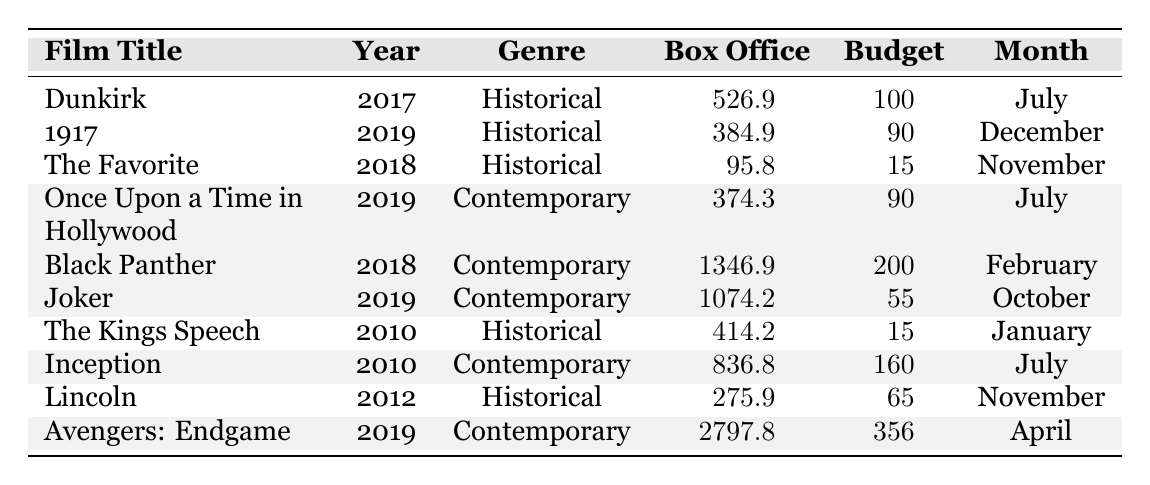What is the box office gross of "Dunkirk"? The table lists "Dunkirk" under the Historical Drama genre with a box office gross of 526.9 million.
Answer: 526.9 million How many historical drama films are in the table? The films categorized as Historical Drama are "Dunkirk," "1917," "The Favorite," "The Kings Speech," and "Lincoln," totaling five films.
Answer: 5 Which film had the highest box office gross, and what was its amount? The film with the highest box office gross is "Avengers: Endgame," at 2797.8 million, which is indicated in the table.
Answer: Avengers: Endgame, 2797.8 million What is the average box office gross of the historical dramas listed? The box office grosses for the historical dramas are 526.9, 384.9, 95.8, 414.2, and 275.9 million. The sum is 1697.7 million, and there are 5 films, so the average is 1697.7/5 = 339.54 million.
Answer: 339.54 million Which genre has a lower average budget, historical dramas or contemporary films? The average budget for historical dramas is (100 + 90 + 15 + 15 + 65)/5 = 57 million, while for contemporary films, it is (90 + 200 + 55 + 160 + 356)/5 = 191.2 million, making historical dramas lower.
Answer: Historical dramas Is "1917" the only historical drama released in December? The table lists "1917" as a historical drama released in December; there are no others mentioned in that month, confirming it's the only one.
Answer: Yes Which contemporary film had the least box office gross, and what was it? Among the contemporary films listed, "Once Upon a Time in Hollywood" has the least box office gross at 374.3 million according to the table.
Answer: Once Upon a Time in Hollywood, 374.3 million What is the total box office gross of all films in the table? To find the total, I sum all box office grosses: 526.9 + 384.9 + 95.8 + 374.3 + 1346.9 + 1074.2 + 414.2 + 836.8 + 275.9 + 2797.8 = 11503.6 million.
Answer: 11503.6 million Which year had the most films featured in the table? Upon checking the release years, 2019 has three films: "1917," "Once Upon a Time in Hollywood," and "Joker." The next most featured year is 2018 with two films, confirming 2019 has the most.
Answer: 2019 What percentage of the total box office gross is attributed to the highest-grossing film? The highest-grossing film is "Avengers: Endgame" with 2797.8 million, and the total gross is 11503.6 million. The percentage is (2797.8 / 11503.6) * 100 = 24.34%.
Answer: 24.34% 